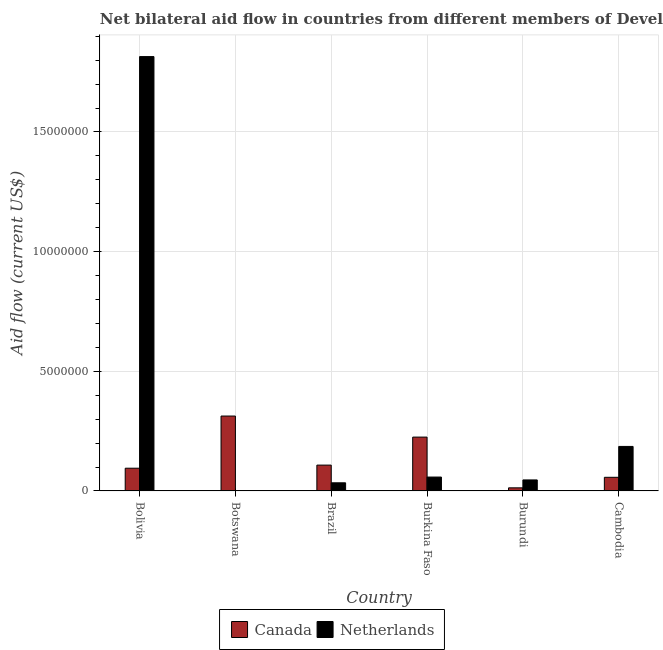How many groups of bars are there?
Ensure brevity in your answer.  6. Are the number of bars on each tick of the X-axis equal?
Keep it short and to the point. Yes. How many bars are there on the 3rd tick from the left?
Your answer should be compact. 2. How many bars are there on the 2nd tick from the right?
Provide a short and direct response. 2. In how many cases, is the number of bars for a given country not equal to the number of legend labels?
Ensure brevity in your answer.  0. What is the amount of aid given by canada in Burundi?
Offer a very short reply. 1.30e+05. Across all countries, what is the maximum amount of aid given by netherlands?
Offer a very short reply. 1.82e+07. Across all countries, what is the minimum amount of aid given by netherlands?
Provide a short and direct response. 10000. In which country was the amount of aid given by canada minimum?
Give a very brief answer. Burundi. What is the total amount of aid given by netherlands in the graph?
Offer a very short reply. 2.14e+07. What is the difference between the amount of aid given by netherlands in Brazil and that in Burundi?
Provide a succinct answer. -1.20e+05. What is the difference between the amount of aid given by netherlands in Cambodia and the amount of aid given by canada in Burkina Faso?
Offer a terse response. -3.90e+05. What is the average amount of aid given by canada per country?
Offer a very short reply. 1.35e+06. What is the difference between the amount of aid given by canada and amount of aid given by netherlands in Bolivia?
Offer a terse response. -1.72e+07. In how many countries, is the amount of aid given by canada greater than 13000000 US$?
Your answer should be compact. 0. What is the ratio of the amount of aid given by canada in Botswana to that in Brazil?
Your response must be concise. 2.9. What is the difference between the highest and the second highest amount of aid given by canada?
Ensure brevity in your answer.  8.80e+05. What is the difference between the highest and the lowest amount of aid given by canada?
Your answer should be compact. 3.00e+06. Is the sum of the amount of aid given by canada in Burundi and Cambodia greater than the maximum amount of aid given by netherlands across all countries?
Make the answer very short. No. Are all the bars in the graph horizontal?
Make the answer very short. No. How many countries are there in the graph?
Give a very brief answer. 6. What is the difference between two consecutive major ticks on the Y-axis?
Give a very brief answer. 5.00e+06. Where does the legend appear in the graph?
Provide a short and direct response. Bottom center. How many legend labels are there?
Your answer should be compact. 2. How are the legend labels stacked?
Give a very brief answer. Horizontal. What is the title of the graph?
Offer a very short reply. Net bilateral aid flow in countries from different members of Development Assistance Committee. What is the label or title of the X-axis?
Your answer should be very brief. Country. What is the label or title of the Y-axis?
Make the answer very short. Aid flow (current US$). What is the Aid flow (current US$) in Canada in Bolivia?
Your answer should be very brief. 9.50e+05. What is the Aid flow (current US$) of Netherlands in Bolivia?
Provide a short and direct response. 1.82e+07. What is the Aid flow (current US$) in Canada in Botswana?
Keep it short and to the point. 3.13e+06. What is the Aid flow (current US$) in Canada in Brazil?
Keep it short and to the point. 1.08e+06. What is the Aid flow (current US$) of Netherlands in Brazil?
Your response must be concise. 3.40e+05. What is the Aid flow (current US$) in Canada in Burkina Faso?
Make the answer very short. 2.25e+06. What is the Aid flow (current US$) in Netherlands in Burkina Faso?
Offer a very short reply. 5.80e+05. What is the Aid flow (current US$) in Netherlands in Burundi?
Your answer should be compact. 4.60e+05. What is the Aid flow (current US$) in Canada in Cambodia?
Give a very brief answer. 5.70e+05. What is the Aid flow (current US$) in Netherlands in Cambodia?
Your answer should be very brief. 1.86e+06. Across all countries, what is the maximum Aid flow (current US$) of Canada?
Your answer should be compact. 3.13e+06. Across all countries, what is the maximum Aid flow (current US$) in Netherlands?
Offer a very short reply. 1.82e+07. Across all countries, what is the minimum Aid flow (current US$) in Canada?
Ensure brevity in your answer.  1.30e+05. What is the total Aid flow (current US$) in Canada in the graph?
Give a very brief answer. 8.11e+06. What is the total Aid flow (current US$) of Netherlands in the graph?
Keep it short and to the point. 2.14e+07. What is the difference between the Aid flow (current US$) of Canada in Bolivia and that in Botswana?
Give a very brief answer. -2.18e+06. What is the difference between the Aid flow (current US$) of Netherlands in Bolivia and that in Botswana?
Your response must be concise. 1.81e+07. What is the difference between the Aid flow (current US$) in Netherlands in Bolivia and that in Brazil?
Your response must be concise. 1.78e+07. What is the difference between the Aid flow (current US$) in Canada in Bolivia and that in Burkina Faso?
Provide a succinct answer. -1.30e+06. What is the difference between the Aid flow (current US$) in Netherlands in Bolivia and that in Burkina Faso?
Your answer should be very brief. 1.76e+07. What is the difference between the Aid flow (current US$) in Canada in Bolivia and that in Burundi?
Offer a terse response. 8.20e+05. What is the difference between the Aid flow (current US$) of Netherlands in Bolivia and that in Burundi?
Your answer should be compact. 1.77e+07. What is the difference between the Aid flow (current US$) in Canada in Bolivia and that in Cambodia?
Make the answer very short. 3.80e+05. What is the difference between the Aid flow (current US$) of Netherlands in Bolivia and that in Cambodia?
Your response must be concise. 1.63e+07. What is the difference between the Aid flow (current US$) of Canada in Botswana and that in Brazil?
Make the answer very short. 2.05e+06. What is the difference between the Aid flow (current US$) in Netherlands in Botswana and that in Brazil?
Your answer should be compact. -3.30e+05. What is the difference between the Aid flow (current US$) of Canada in Botswana and that in Burkina Faso?
Provide a short and direct response. 8.80e+05. What is the difference between the Aid flow (current US$) of Netherlands in Botswana and that in Burkina Faso?
Make the answer very short. -5.70e+05. What is the difference between the Aid flow (current US$) in Canada in Botswana and that in Burundi?
Make the answer very short. 3.00e+06. What is the difference between the Aid flow (current US$) in Netherlands in Botswana and that in Burundi?
Your response must be concise. -4.50e+05. What is the difference between the Aid flow (current US$) in Canada in Botswana and that in Cambodia?
Your answer should be compact. 2.56e+06. What is the difference between the Aid flow (current US$) in Netherlands in Botswana and that in Cambodia?
Make the answer very short. -1.85e+06. What is the difference between the Aid flow (current US$) of Canada in Brazil and that in Burkina Faso?
Provide a short and direct response. -1.17e+06. What is the difference between the Aid flow (current US$) in Netherlands in Brazil and that in Burkina Faso?
Offer a very short reply. -2.40e+05. What is the difference between the Aid flow (current US$) in Canada in Brazil and that in Burundi?
Your answer should be compact. 9.50e+05. What is the difference between the Aid flow (current US$) in Canada in Brazil and that in Cambodia?
Your answer should be very brief. 5.10e+05. What is the difference between the Aid flow (current US$) in Netherlands in Brazil and that in Cambodia?
Provide a succinct answer. -1.52e+06. What is the difference between the Aid flow (current US$) of Canada in Burkina Faso and that in Burundi?
Your response must be concise. 2.12e+06. What is the difference between the Aid flow (current US$) in Canada in Burkina Faso and that in Cambodia?
Provide a short and direct response. 1.68e+06. What is the difference between the Aid flow (current US$) in Netherlands in Burkina Faso and that in Cambodia?
Offer a terse response. -1.28e+06. What is the difference between the Aid flow (current US$) in Canada in Burundi and that in Cambodia?
Keep it short and to the point. -4.40e+05. What is the difference between the Aid flow (current US$) in Netherlands in Burundi and that in Cambodia?
Your answer should be compact. -1.40e+06. What is the difference between the Aid flow (current US$) of Canada in Bolivia and the Aid flow (current US$) of Netherlands in Botswana?
Your answer should be very brief. 9.40e+05. What is the difference between the Aid flow (current US$) of Canada in Bolivia and the Aid flow (current US$) of Netherlands in Brazil?
Keep it short and to the point. 6.10e+05. What is the difference between the Aid flow (current US$) in Canada in Bolivia and the Aid flow (current US$) in Netherlands in Burundi?
Your response must be concise. 4.90e+05. What is the difference between the Aid flow (current US$) in Canada in Bolivia and the Aid flow (current US$) in Netherlands in Cambodia?
Offer a terse response. -9.10e+05. What is the difference between the Aid flow (current US$) in Canada in Botswana and the Aid flow (current US$) in Netherlands in Brazil?
Offer a terse response. 2.79e+06. What is the difference between the Aid flow (current US$) of Canada in Botswana and the Aid flow (current US$) of Netherlands in Burkina Faso?
Your response must be concise. 2.55e+06. What is the difference between the Aid flow (current US$) in Canada in Botswana and the Aid flow (current US$) in Netherlands in Burundi?
Give a very brief answer. 2.67e+06. What is the difference between the Aid flow (current US$) of Canada in Botswana and the Aid flow (current US$) of Netherlands in Cambodia?
Provide a short and direct response. 1.27e+06. What is the difference between the Aid flow (current US$) of Canada in Brazil and the Aid flow (current US$) of Netherlands in Burkina Faso?
Give a very brief answer. 5.00e+05. What is the difference between the Aid flow (current US$) in Canada in Brazil and the Aid flow (current US$) in Netherlands in Burundi?
Give a very brief answer. 6.20e+05. What is the difference between the Aid flow (current US$) in Canada in Brazil and the Aid flow (current US$) in Netherlands in Cambodia?
Give a very brief answer. -7.80e+05. What is the difference between the Aid flow (current US$) of Canada in Burkina Faso and the Aid flow (current US$) of Netherlands in Burundi?
Offer a very short reply. 1.79e+06. What is the difference between the Aid flow (current US$) in Canada in Burkina Faso and the Aid flow (current US$) in Netherlands in Cambodia?
Offer a terse response. 3.90e+05. What is the difference between the Aid flow (current US$) in Canada in Burundi and the Aid flow (current US$) in Netherlands in Cambodia?
Provide a short and direct response. -1.73e+06. What is the average Aid flow (current US$) of Canada per country?
Provide a short and direct response. 1.35e+06. What is the average Aid flow (current US$) in Netherlands per country?
Make the answer very short. 3.57e+06. What is the difference between the Aid flow (current US$) of Canada and Aid flow (current US$) of Netherlands in Bolivia?
Offer a terse response. -1.72e+07. What is the difference between the Aid flow (current US$) in Canada and Aid flow (current US$) in Netherlands in Botswana?
Your answer should be compact. 3.12e+06. What is the difference between the Aid flow (current US$) in Canada and Aid flow (current US$) in Netherlands in Brazil?
Provide a succinct answer. 7.40e+05. What is the difference between the Aid flow (current US$) of Canada and Aid flow (current US$) of Netherlands in Burkina Faso?
Provide a succinct answer. 1.67e+06. What is the difference between the Aid flow (current US$) in Canada and Aid flow (current US$) in Netherlands in Burundi?
Your response must be concise. -3.30e+05. What is the difference between the Aid flow (current US$) of Canada and Aid flow (current US$) of Netherlands in Cambodia?
Your answer should be compact. -1.29e+06. What is the ratio of the Aid flow (current US$) in Canada in Bolivia to that in Botswana?
Offer a very short reply. 0.3. What is the ratio of the Aid flow (current US$) of Netherlands in Bolivia to that in Botswana?
Give a very brief answer. 1815. What is the ratio of the Aid flow (current US$) of Canada in Bolivia to that in Brazil?
Offer a terse response. 0.88. What is the ratio of the Aid flow (current US$) of Netherlands in Bolivia to that in Brazil?
Your response must be concise. 53.38. What is the ratio of the Aid flow (current US$) of Canada in Bolivia to that in Burkina Faso?
Offer a terse response. 0.42. What is the ratio of the Aid flow (current US$) of Netherlands in Bolivia to that in Burkina Faso?
Offer a very short reply. 31.29. What is the ratio of the Aid flow (current US$) of Canada in Bolivia to that in Burundi?
Ensure brevity in your answer.  7.31. What is the ratio of the Aid flow (current US$) of Netherlands in Bolivia to that in Burundi?
Your response must be concise. 39.46. What is the ratio of the Aid flow (current US$) of Canada in Bolivia to that in Cambodia?
Give a very brief answer. 1.67. What is the ratio of the Aid flow (current US$) in Netherlands in Bolivia to that in Cambodia?
Ensure brevity in your answer.  9.76. What is the ratio of the Aid flow (current US$) of Canada in Botswana to that in Brazil?
Make the answer very short. 2.9. What is the ratio of the Aid flow (current US$) of Netherlands in Botswana to that in Brazil?
Keep it short and to the point. 0.03. What is the ratio of the Aid flow (current US$) in Canada in Botswana to that in Burkina Faso?
Give a very brief answer. 1.39. What is the ratio of the Aid flow (current US$) of Netherlands in Botswana to that in Burkina Faso?
Provide a short and direct response. 0.02. What is the ratio of the Aid flow (current US$) in Canada in Botswana to that in Burundi?
Your answer should be compact. 24.08. What is the ratio of the Aid flow (current US$) in Netherlands in Botswana to that in Burundi?
Give a very brief answer. 0.02. What is the ratio of the Aid flow (current US$) in Canada in Botswana to that in Cambodia?
Your answer should be compact. 5.49. What is the ratio of the Aid flow (current US$) in Netherlands in Botswana to that in Cambodia?
Give a very brief answer. 0.01. What is the ratio of the Aid flow (current US$) of Canada in Brazil to that in Burkina Faso?
Make the answer very short. 0.48. What is the ratio of the Aid flow (current US$) of Netherlands in Brazil to that in Burkina Faso?
Your response must be concise. 0.59. What is the ratio of the Aid flow (current US$) in Canada in Brazil to that in Burundi?
Your answer should be very brief. 8.31. What is the ratio of the Aid flow (current US$) of Netherlands in Brazil to that in Burundi?
Your answer should be very brief. 0.74. What is the ratio of the Aid flow (current US$) of Canada in Brazil to that in Cambodia?
Give a very brief answer. 1.89. What is the ratio of the Aid flow (current US$) in Netherlands in Brazil to that in Cambodia?
Provide a short and direct response. 0.18. What is the ratio of the Aid flow (current US$) of Canada in Burkina Faso to that in Burundi?
Provide a short and direct response. 17.31. What is the ratio of the Aid flow (current US$) in Netherlands in Burkina Faso to that in Burundi?
Give a very brief answer. 1.26. What is the ratio of the Aid flow (current US$) in Canada in Burkina Faso to that in Cambodia?
Provide a succinct answer. 3.95. What is the ratio of the Aid flow (current US$) in Netherlands in Burkina Faso to that in Cambodia?
Offer a terse response. 0.31. What is the ratio of the Aid flow (current US$) of Canada in Burundi to that in Cambodia?
Provide a short and direct response. 0.23. What is the ratio of the Aid flow (current US$) of Netherlands in Burundi to that in Cambodia?
Keep it short and to the point. 0.25. What is the difference between the highest and the second highest Aid flow (current US$) of Canada?
Offer a very short reply. 8.80e+05. What is the difference between the highest and the second highest Aid flow (current US$) of Netherlands?
Make the answer very short. 1.63e+07. What is the difference between the highest and the lowest Aid flow (current US$) in Netherlands?
Keep it short and to the point. 1.81e+07. 